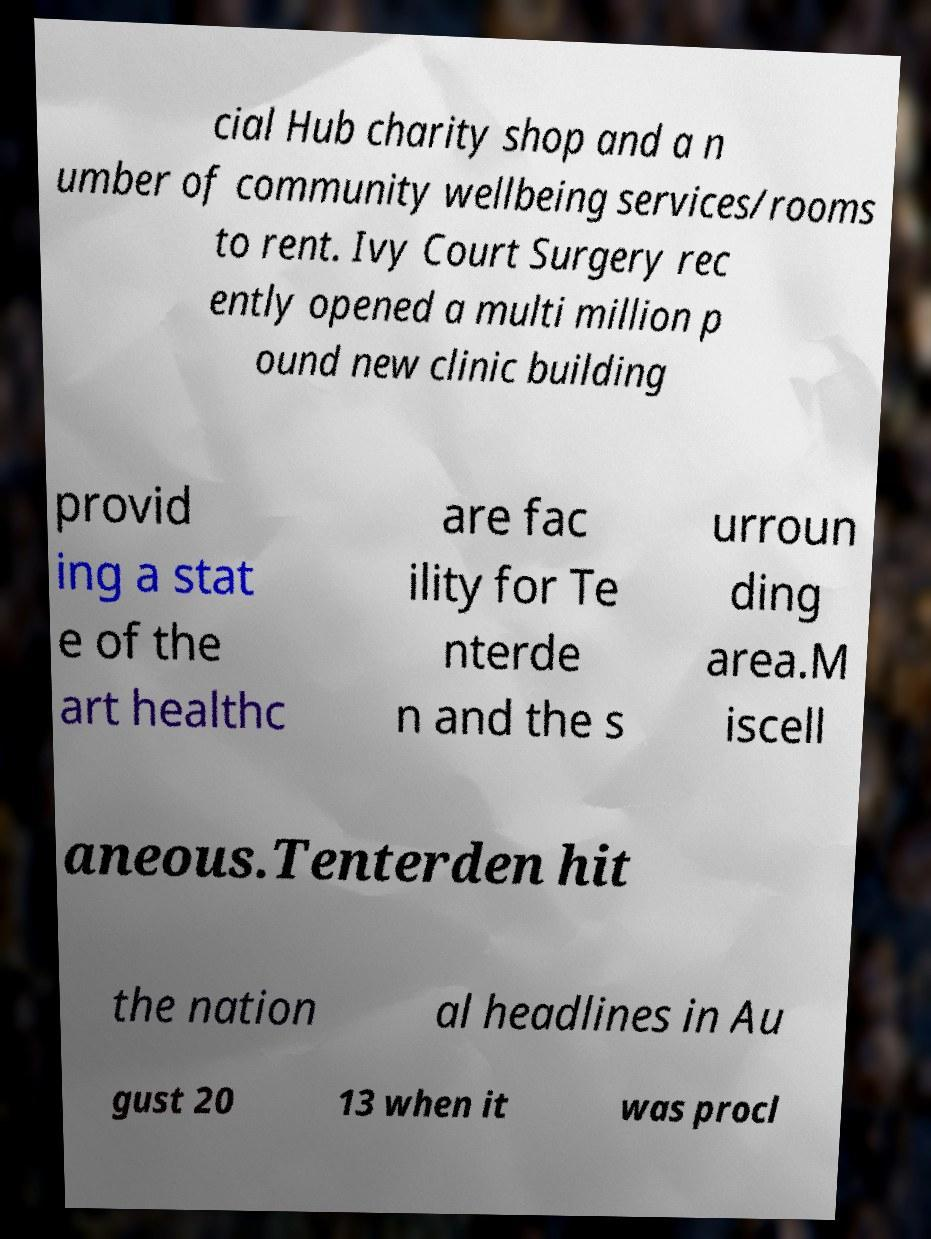Can you accurately transcribe the text from the provided image for me? cial Hub charity shop and a n umber of community wellbeing services/rooms to rent. Ivy Court Surgery rec ently opened a multi million p ound new clinic building provid ing a stat e of the art healthc are fac ility for Te nterde n and the s urroun ding area.M iscell aneous.Tenterden hit the nation al headlines in Au gust 20 13 when it was procl 